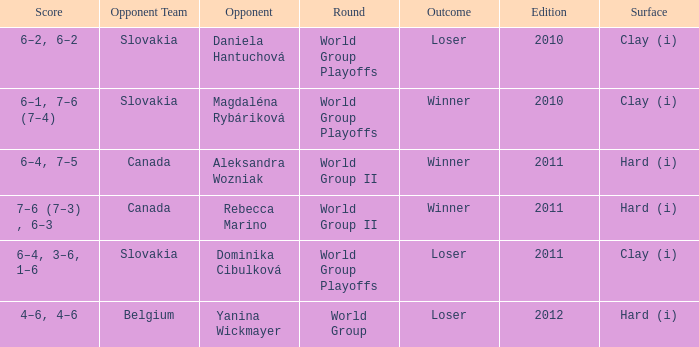What was the game edition when they played on the clay (i) surface and the outcome was a winner? 2010.0. 